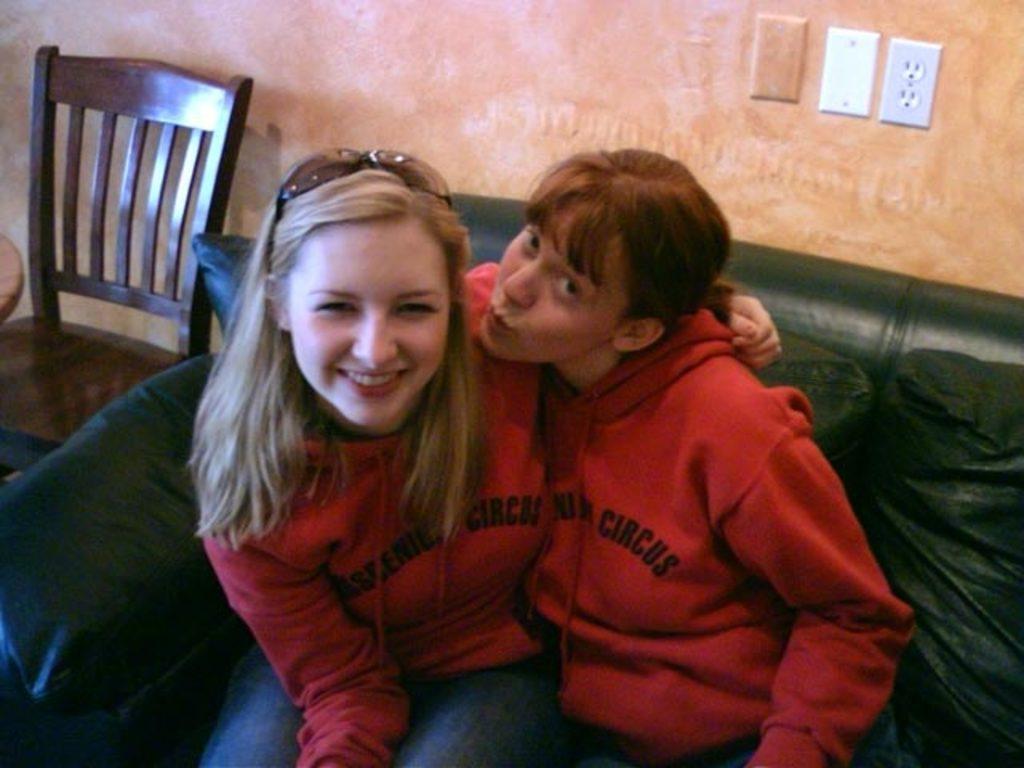How would you summarize this image in a sentence or two? In this picture there are two women sitting on the couch with some pillows and one of them is smiling and another one is looking at the camera and this is there beside them there is a chair and in backdrop there is a wall 